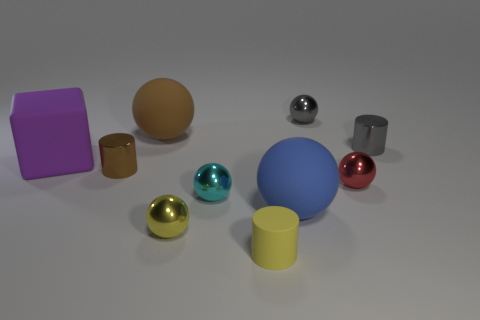The other tiny object that is the same color as the small matte object is what shape?
Offer a very short reply. Sphere. How many objects are big matte spheres that are to the left of the tiny yellow sphere or tiny things in front of the yellow shiny ball?
Make the answer very short. 2. What is the size of the blue ball that is made of the same material as the small yellow cylinder?
Provide a succinct answer. Large. Does the big object in front of the cyan metal ball have the same shape as the tiny yellow rubber thing?
Give a very brief answer. No. There is a thing that is the same color as the matte cylinder; what is its size?
Offer a terse response. Small. How many blue objects are shiny objects or blocks?
Provide a succinct answer. 0. How many other objects are the same shape as the small red metal object?
Give a very brief answer. 5. There is a rubber thing that is both right of the tiny yellow ball and behind the small yellow rubber thing; what is its shape?
Make the answer very short. Sphere. There is a big blue matte sphere; are there any large matte objects in front of it?
Keep it short and to the point. No. The other gray object that is the same shape as the tiny matte object is what size?
Make the answer very short. Small. 